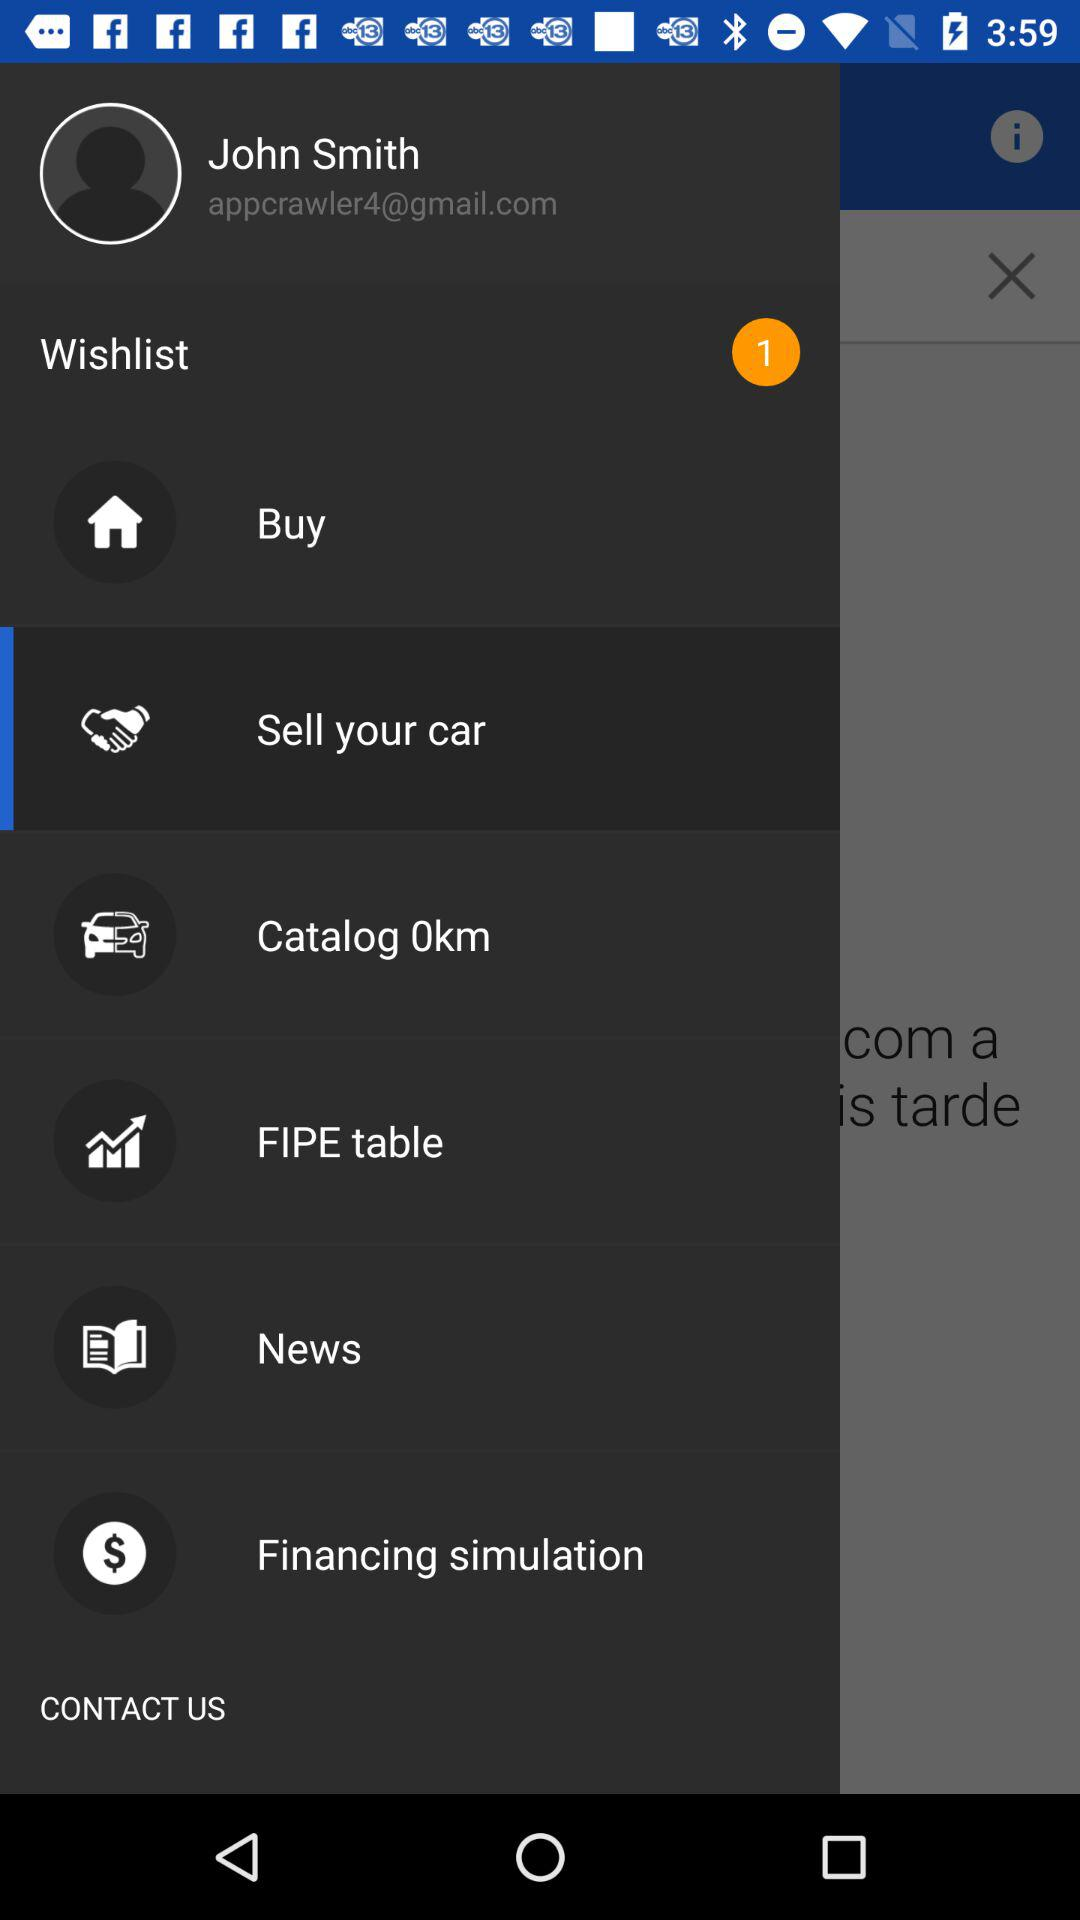What is the email address? The email address is appcrawler4@gmail.com. 